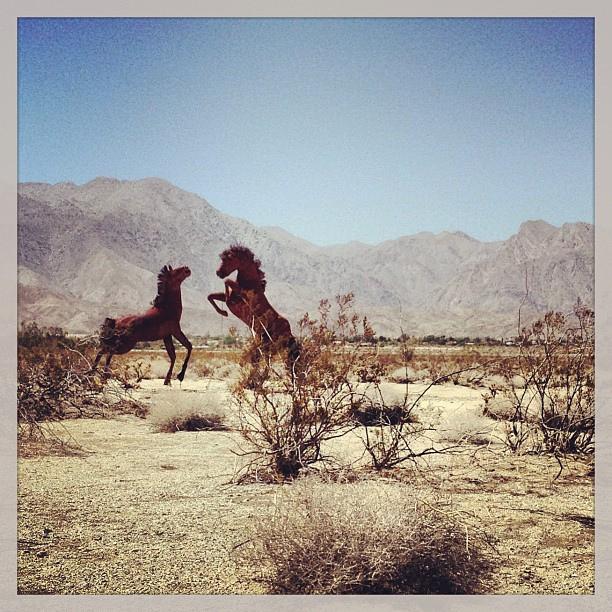What season is this?
Short answer required. Summer. There are two different kinds of animals, what are they?
Quick response, please. Horses. Is there green anywhere?
Quick response, please. No. How many feet is the horse on the right standing on?
Quick response, please. 2. Would this be a good place for camping?
Keep it brief. No. What kind of climate are they in?
Short answer required. Desert. What is the horse on the right doing?
Keep it brief. Standing. What is on the ground?
Give a very brief answer. Dirt. 